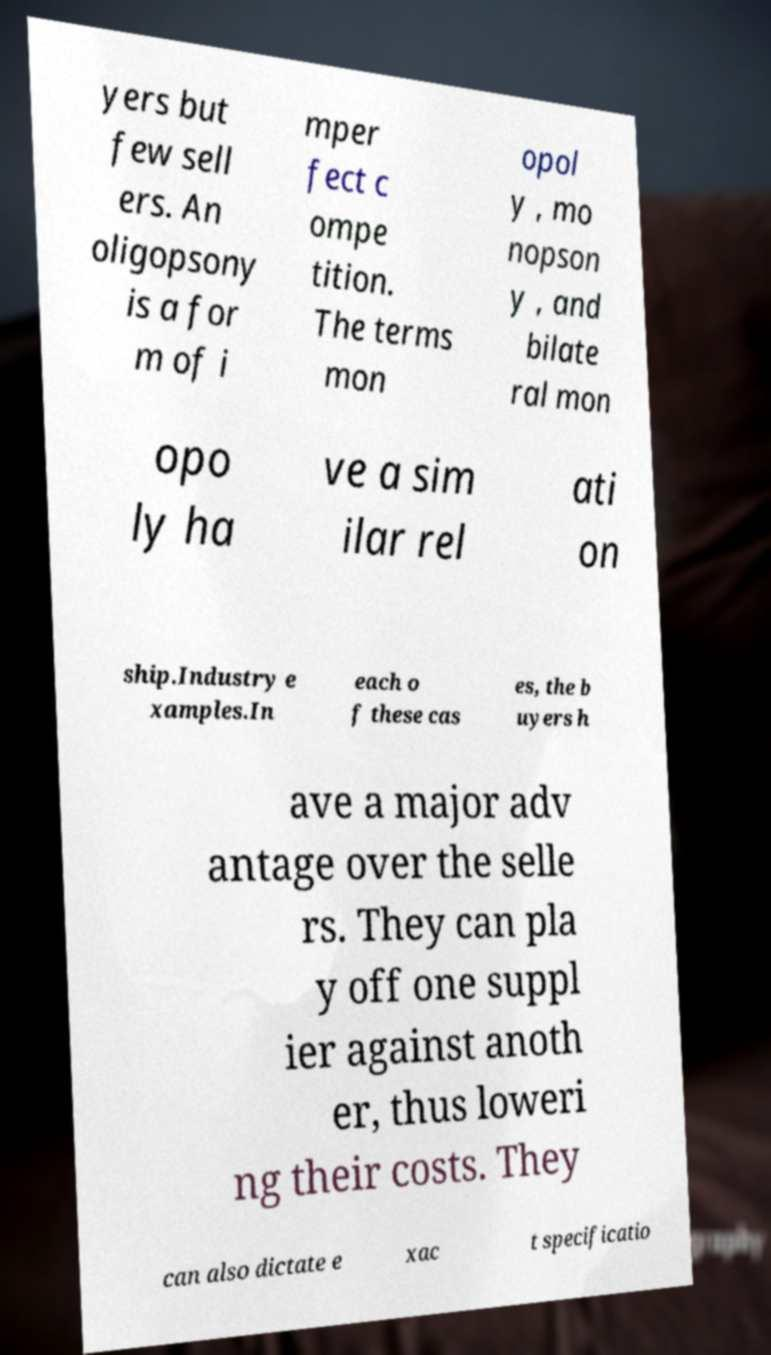I need the written content from this picture converted into text. Can you do that? yers but few sell ers. An oligopsony is a for m of i mper fect c ompe tition. The terms mon opol y , mo nopson y , and bilate ral mon opo ly ha ve a sim ilar rel ati on ship.Industry e xamples.In each o f these cas es, the b uyers h ave a major adv antage over the selle rs. They can pla y off one suppl ier against anoth er, thus loweri ng their costs. They can also dictate e xac t specificatio 